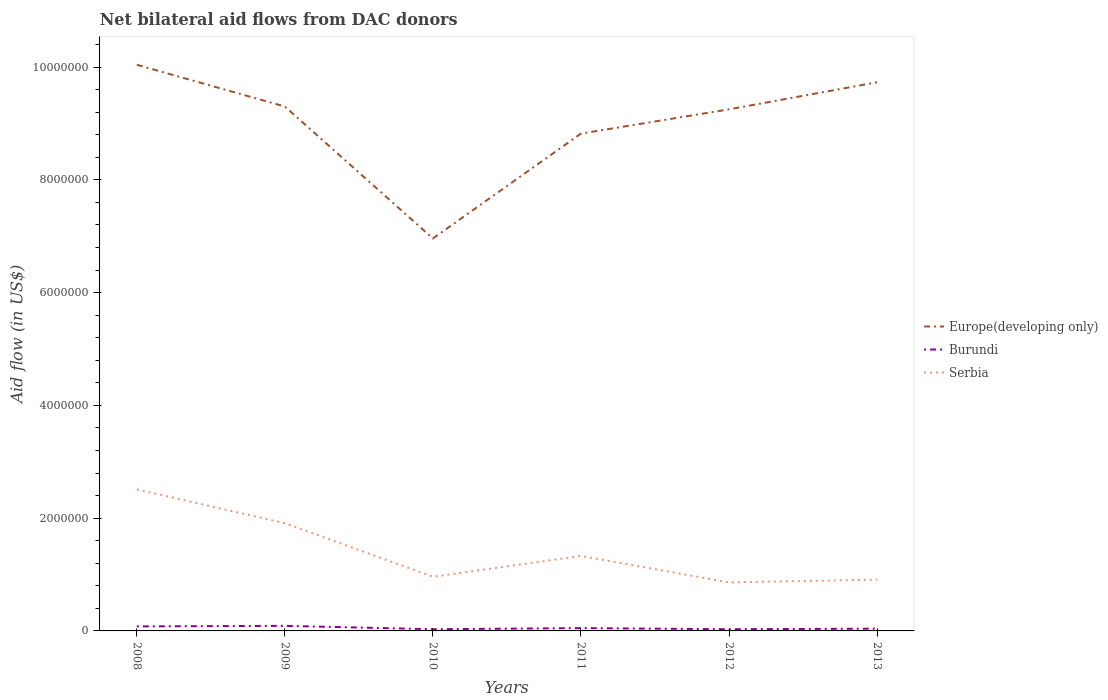Does the line corresponding to Europe(developing only) intersect with the line corresponding to Burundi?
Give a very brief answer. No. Is the number of lines equal to the number of legend labels?
Provide a succinct answer. Yes. Across all years, what is the maximum net bilateral aid flow in Serbia?
Your response must be concise. 8.60e+05. In which year was the net bilateral aid flow in Serbia maximum?
Make the answer very short. 2012. What is the total net bilateral aid flow in Serbia in the graph?
Make the answer very short. 4.70e+05. What is the difference between the highest and the second highest net bilateral aid flow in Burundi?
Your answer should be compact. 6.00e+04. What is the difference between the highest and the lowest net bilateral aid flow in Serbia?
Give a very brief answer. 2. Is the net bilateral aid flow in Serbia strictly greater than the net bilateral aid flow in Burundi over the years?
Offer a terse response. No. What is the difference between two consecutive major ticks on the Y-axis?
Provide a short and direct response. 2.00e+06. Are the values on the major ticks of Y-axis written in scientific E-notation?
Give a very brief answer. No. What is the title of the graph?
Provide a short and direct response. Net bilateral aid flows from DAC donors. What is the label or title of the X-axis?
Make the answer very short. Years. What is the label or title of the Y-axis?
Provide a succinct answer. Aid flow (in US$). What is the Aid flow (in US$) of Europe(developing only) in 2008?
Offer a very short reply. 1.00e+07. What is the Aid flow (in US$) in Serbia in 2008?
Offer a terse response. 2.51e+06. What is the Aid flow (in US$) of Europe(developing only) in 2009?
Offer a very short reply. 9.30e+06. What is the Aid flow (in US$) in Burundi in 2009?
Your answer should be very brief. 9.00e+04. What is the Aid flow (in US$) in Serbia in 2009?
Your response must be concise. 1.91e+06. What is the Aid flow (in US$) in Europe(developing only) in 2010?
Provide a short and direct response. 6.96e+06. What is the Aid flow (in US$) of Burundi in 2010?
Provide a short and direct response. 3.00e+04. What is the Aid flow (in US$) of Serbia in 2010?
Provide a short and direct response. 9.60e+05. What is the Aid flow (in US$) of Europe(developing only) in 2011?
Your answer should be compact. 8.82e+06. What is the Aid flow (in US$) of Burundi in 2011?
Provide a short and direct response. 5.00e+04. What is the Aid flow (in US$) of Serbia in 2011?
Provide a succinct answer. 1.33e+06. What is the Aid flow (in US$) of Europe(developing only) in 2012?
Keep it short and to the point. 9.25e+06. What is the Aid flow (in US$) of Serbia in 2012?
Offer a terse response. 8.60e+05. What is the Aid flow (in US$) in Europe(developing only) in 2013?
Your answer should be very brief. 9.73e+06. What is the Aid flow (in US$) of Burundi in 2013?
Offer a terse response. 4.00e+04. What is the Aid flow (in US$) of Serbia in 2013?
Offer a terse response. 9.10e+05. Across all years, what is the maximum Aid flow (in US$) in Europe(developing only)?
Provide a succinct answer. 1.00e+07. Across all years, what is the maximum Aid flow (in US$) in Burundi?
Your answer should be very brief. 9.00e+04. Across all years, what is the maximum Aid flow (in US$) of Serbia?
Your response must be concise. 2.51e+06. Across all years, what is the minimum Aid flow (in US$) of Europe(developing only)?
Your answer should be very brief. 6.96e+06. Across all years, what is the minimum Aid flow (in US$) in Burundi?
Offer a terse response. 3.00e+04. Across all years, what is the minimum Aid flow (in US$) of Serbia?
Your response must be concise. 8.60e+05. What is the total Aid flow (in US$) in Europe(developing only) in the graph?
Make the answer very short. 5.41e+07. What is the total Aid flow (in US$) of Serbia in the graph?
Your answer should be compact. 8.48e+06. What is the difference between the Aid flow (in US$) of Europe(developing only) in 2008 and that in 2009?
Give a very brief answer. 7.40e+05. What is the difference between the Aid flow (in US$) of Burundi in 2008 and that in 2009?
Your answer should be very brief. -10000. What is the difference between the Aid flow (in US$) in Europe(developing only) in 2008 and that in 2010?
Provide a short and direct response. 3.08e+06. What is the difference between the Aid flow (in US$) in Burundi in 2008 and that in 2010?
Keep it short and to the point. 5.00e+04. What is the difference between the Aid flow (in US$) in Serbia in 2008 and that in 2010?
Your answer should be compact. 1.55e+06. What is the difference between the Aid flow (in US$) in Europe(developing only) in 2008 and that in 2011?
Ensure brevity in your answer.  1.22e+06. What is the difference between the Aid flow (in US$) of Serbia in 2008 and that in 2011?
Offer a very short reply. 1.18e+06. What is the difference between the Aid flow (in US$) of Europe(developing only) in 2008 and that in 2012?
Give a very brief answer. 7.90e+05. What is the difference between the Aid flow (in US$) of Burundi in 2008 and that in 2012?
Your answer should be compact. 5.00e+04. What is the difference between the Aid flow (in US$) in Serbia in 2008 and that in 2012?
Your response must be concise. 1.65e+06. What is the difference between the Aid flow (in US$) of Europe(developing only) in 2008 and that in 2013?
Your response must be concise. 3.10e+05. What is the difference between the Aid flow (in US$) of Burundi in 2008 and that in 2013?
Make the answer very short. 4.00e+04. What is the difference between the Aid flow (in US$) of Serbia in 2008 and that in 2013?
Provide a short and direct response. 1.60e+06. What is the difference between the Aid flow (in US$) in Europe(developing only) in 2009 and that in 2010?
Provide a short and direct response. 2.34e+06. What is the difference between the Aid flow (in US$) of Serbia in 2009 and that in 2010?
Provide a succinct answer. 9.50e+05. What is the difference between the Aid flow (in US$) in Europe(developing only) in 2009 and that in 2011?
Keep it short and to the point. 4.80e+05. What is the difference between the Aid flow (in US$) in Burundi in 2009 and that in 2011?
Keep it short and to the point. 4.00e+04. What is the difference between the Aid flow (in US$) in Serbia in 2009 and that in 2011?
Keep it short and to the point. 5.80e+05. What is the difference between the Aid flow (in US$) in Europe(developing only) in 2009 and that in 2012?
Provide a succinct answer. 5.00e+04. What is the difference between the Aid flow (in US$) of Serbia in 2009 and that in 2012?
Your answer should be compact. 1.05e+06. What is the difference between the Aid flow (in US$) of Europe(developing only) in 2009 and that in 2013?
Provide a short and direct response. -4.30e+05. What is the difference between the Aid flow (in US$) in Burundi in 2009 and that in 2013?
Your answer should be compact. 5.00e+04. What is the difference between the Aid flow (in US$) of Serbia in 2009 and that in 2013?
Your response must be concise. 1.00e+06. What is the difference between the Aid flow (in US$) in Europe(developing only) in 2010 and that in 2011?
Make the answer very short. -1.86e+06. What is the difference between the Aid flow (in US$) of Burundi in 2010 and that in 2011?
Make the answer very short. -2.00e+04. What is the difference between the Aid flow (in US$) of Serbia in 2010 and that in 2011?
Your answer should be very brief. -3.70e+05. What is the difference between the Aid flow (in US$) in Europe(developing only) in 2010 and that in 2012?
Your response must be concise. -2.29e+06. What is the difference between the Aid flow (in US$) in Burundi in 2010 and that in 2012?
Make the answer very short. 0. What is the difference between the Aid flow (in US$) in Serbia in 2010 and that in 2012?
Offer a very short reply. 1.00e+05. What is the difference between the Aid flow (in US$) of Europe(developing only) in 2010 and that in 2013?
Make the answer very short. -2.77e+06. What is the difference between the Aid flow (in US$) of Burundi in 2010 and that in 2013?
Your answer should be very brief. -10000. What is the difference between the Aid flow (in US$) of Serbia in 2010 and that in 2013?
Provide a succinct answer. 5.00e+04. What is the difference between the Aid flow (in US$) in Europe(developing only) in 2011 and that in 2012?
Your response must be concise. -4.30e+05. What is the difference between the Aid flow (in US$) in Burundi in 2011 and that in 2012?
Your response must be concise. 2.00e+04. What is the difference between the Aid flow (in US$) in Serbia in 2011 and that in 2012?
Offer a very short reply. 4.70e+05. What is the difference between the Aid flow (in US$) in Europe(developing only) in 2011 and that in 2013?
Your response must be concise. -9.10e+05. What is the difference between the Aid flow (in US$) of Burundi in 2011 and that in 2013?
Your answer should be compact. 10000. What is the difference between the Aid flow (in US$) of Europe(developing only) in 2012 and that in 2013?
Keep it short and to the point. -4.80e+05. What is the difference between the Aid flow (in US$) in Burundi in 2012 and that in 2013?
Keep it short and to the point. -10000. What is the difference between the Aid flow (in US$) in Serbia in 2012 and that in 2013?
Provide a short and direct response. -5.00e+04. What is the difference between the Aid flow (in US$) in Europe(developing only) in 2008 and the Aid flow (in US$) in Burundi in 2009?
Your answer should be very brief. 9.95e+06. What is the difference between the Aid flow (in US$) in Europe(developing only) in 2008 and the Aid flow (in US$) in Serbia in 2009?
Your response must be concise. 8.13e+06. What is the difference between the Aid flow (in US$) of Burundi in 2008 and the Aid flow (in US$) of Serbia in 2009?
Provide a succinct answer. -1.83e+06. What is the difference between the Aid flow (in US$) in Europe(developing only) in 2008 and the Aid flow (in US$) in Burundi in 2010?
Your answer should be very brief. 1.00e+07. What is the difference between the Aid flow (in US$) of Europe(developing only) in 2008 and the Aid flow (in US$) of Serbia in 2010?
Provide a short and direct response. 9.08e+06. What is the difference between the Aid flow (in US$) of Burundi in 2008 and the Aid flow (in US$) of Serbia in 2010?
Offer a very short reply. -8.80e+05. What is the difference between the Aid flow (in US$) of Europe(developing only) in 2008 and the Aid flow (in US$) of Burundi in 2011?
Ensure brevity in your answer.  9.99e+06. What is the difference between the Aid flow (in US$) of Europe(developing only) in 2008 and the Aid flow (in US$) of Serbia in 2011?
Your response must be concise. 8.71e+06. What is the difference between the Aid flow (in US$) of Burundi in 2008 and the Aid flow (in US$) of Serbia in 2011?
Give a very brief answer. -1.25e+06. What is the difference between the Aid flow (in US$) of Europe(developing only) in 2008 and the Aid flow (in US$) of Burundi in 2012?
Offer a terse response. 1.00e+07. What is the difference between the Aid flow (in US$) of Europe(developing only) in 2008 and the Aid flow (in US$) of Serbia in 2012?
Ensure brevity in your answer.  9.18e+06. What is the difference between the Aid flow (in US$) of Burundi in 2008 and the Aid flow (in US$) of Serbia in 2012?
Offer a terse response. -7.80e+05. What is the difference between the Aid flow (in US$) in Europe(developing only) in 2008 and the Aid flow (in US$) in Burundi in 2013?
Your response must be concise. 1.00e+07. What is the difference between the Aid flow (in US$) in Europe(developing only) in 2008 and the Aid flow (in US$) in Serbia in 2013?
Make the answer very short. 9.13e+06. What is the difference between the Aid flow (in US$) of Burundi in 2008 and the Aid flow (in US$) of Serbia in 2013?
Your answer should be compact. -8.30e+05. What is the difference between the Aid flow (in US$) of Europe(developing only) in 2009 and the Aid flow (in US$) of Burundi in 2010?
Make the answer very short. 9.27e+06. What is the difference between the Aid flow (in US$) of Europe(developing only) in 2009 and the Aid flow (in US$) of Serbia in 2010?
Offer a very short reply. 8.34e+06. What is the difference between the Aid flow (in US$) in Burundi in 2009 and the Aid flow (in US$) in Serbia in 2010?
Provide a short and direct response. -8.70e+05. What is the difference between the Aid flow (in US$) in Europe(developing only) in 2009 and the Aid flow (in US$) in Burundi in 2011?
Offer a terse response. 9.25e+06. What is the difference between the Aid flow (in US$) in Europe(developing only) in 2009 and the Aid flow (in US$) in Serbia in 2011?
Keep it short and to the point. 7.97e+06. What is the difference between the Aid flow (in US$) in Burundi in 2009 and the Aid flow (in US$) in Serbia in 2011?
Provide a succinct answer. -1.24e+06. What is the difference between the Aid flow (in US$) of Europe(developing only) in 2009 and the Aid flow (in US$) of Burundi in 2012?
Your answer should be very brief. 9.27e+06. What is the difference between the Aid flow (in US$) of Europe(developing only) in 2009 and the Aid flow (in US$) of Serbia in 2012?
Ensure brevity in your answer.  8.44e+06. What is the difference between the Aid flow (in US$) in Burundi in 2009 and the Aid flow (in US$) in Serbia in 2012?
Offer a terse response. -7.70e+05. What is the difference between the Aid flow (in US$) of Europe(developing only) in 2009 and the Aid flow (in US$) of Burundi in 2013?
Provide a short and direct response. 9.26e+06. What is the difference between the Aid flow (in US$) in Europe(developing only) in 2009 and the Aid flow (in US$) in Serbia in 2013?
Your response must be concise. 8.39e+06. What is the difference between the Aid flow (in US$) of Burundi in 2009 and the Aid flow (in US$) of Serbia in 2013?
Offer a terse response. -8.20e+05. What is the difference between the Aid flow (in US$) of Europe(developing only) in 2010 and the Aid flow (in US$) of Burundi in 2011?
Offer a terse response. 6.91e+06. What is the difference between the Aid flow (in US$) of Europe(developing only) in 2010 and the Aid flow (in US$) of Serbia in 2011?
Ensure brevity in your answer.  5.63e+06. What is the difference between the Aid flow (in US$) in Burundi in 2010 and the Aid flow (in US$) in Serbia in 2011?
Provide a short and direct response. -1.30e+06. What is the difference between the Aid flow (in US$) of Europe(developing only) in 2010 and the Aid flow (in US$) of Burundi in 2012?
Provide a succinct answer. 6.93e+06. What is the difference between the Aid flow (in US$) in Europe(developing only) in 2010 and the Aid flow (in US$) in Serbia in 2012?
Provide a succinct answer. 6.10e+06. What is the difference between the Aid flow (in US$) in Burundi in 2010 and the Aid flow (in US$) in Serbia in 2012?
Keep it short and to the point. -8.30e+05. What is the difference between the Aid flow (in US$) of Europe(developing only) in 2010 and the Aid flow (in US$) of Burundi in 2013?
Offer a very short reply. 6.92e+06. What is the difference between the Aid flow (in US$) in Europe(developing only) in 2010 and the Aid flow (in US$) in Serbia in 2013?
Make the answer very short. 6.05e+06. What is the difference between the Aid flow (in US$) in Burundi in 2010 and the Aid flow (in US$) in Serbia in 2013?
Offer a very short reply. -8.80e+05. What is the difference between the Aid flow (in US$) of Europe(developing only) in 2011 and the Aid flow (in US$) of Burundi in 2012?
Your answer should be very brief. 8.79e+06. What is the difference between the Aid flow (in US$) of Europe(developing only) in 2011 and the Aid flow (in US$) of Serbia in 2012?
Provide a succinct answer. 7.96e+06. What is the difference between the Aid flow (in US$) of Burundi in 2011 and the Aid flow (in US$) of Serbia in 2012?
Keep it short and to the point. -8.10e+05. What is the difference between the Aid flow (in US$) in Europe(developing only) in 2011 and the Aid flow (in US$) in Burundi in 2013?
Give a very brief answer. 8.78e+06. What is the difference between the Aid flow (in US$) of Europe(developing only) in 2011 and the Aid flow (in US$) of Serbia in 2013?
Your answer should be very brief. 7.91e+06. What is the difference between the Aid flow (in US$) of Burundi in 2011 and the Aid flow (in US$) of Serbia in 2013?
Keep it short and to the point. -8.60e+05. What is the difference between the Aid flow (in US$) in Europe(developing only) in 2012 and the Aid flow (in US$) in Burundi in 2013?
Your answer should be compact. 9.21e+06. What is the difference between the Aid flow (in US$) in Europe(developing only) in 2012 and the Aid flow (in US$) in Serbia in 2013?
Give a very brief answer. 8.34e+06. What is the difference between the Aid flow (in US$) of Burundi in 2012 and the Aid flow (in US$) of Serbia in 2013?
Make the answer very short. -8.80e+05. What is the average Aid flow (in US$) in Europe(developing only) per year?
Offer a terse response. 9.02e+06. What is the average Aid flow (in US$) in Burundi per year?
Your answer should be compact. 5.33e+04. What is the average Aid flow (in US$) of Serbia per year?
Provide a succinct answer. 1.41e+06. In the year 2008, what is the difference between the Aid flow (in US$) of Europe(developing only) and Aid flow (in US$) of Burundi?
Keep it short and to the point. 9.96e+06. In the year 2008, what is the difference between the Aid flow (in US$) in Europe(developing only) and Aid flow (in US$) in Serbia?
Offer a terse response. 7.53e+06. In the year 2008, what is the difference between the Aid flow (in US$) in Burundi and Aid flow (in US$) in Serbia?
Give a very brief answer. -2.43e+06. In the year 2009, what is the difference between the Aid flow (in US$) in Europe(developing only) and Aid flow (in US$) in Burundi?
Keep it short and to the point. 9.21e+06. In the year 2009, what is the difference between the Aid flow (in US$) in Europe(developing only) and Aid flow (in US$) in Serbia?
Your response must be concise. 7.39e+06. In the year 2009, what is the difference between the Aid flow (in US$) of Burundi and Aid flow (in US$) of Serbia?
Provide a short and direct response. -1.82e+06. In the year 2010, what is the difference between the Aid flow (in US$) in Europe(developing only) and Aid flow (in US$) in Burundi?
Make the answer very short. 6.93e+06. In the year 2010, what is the difference between the Aid flow (in US$) of Europe(developing only) and Aid flow (in US$) of Serbia?
Provide a succinct answer. 6.00e+06. In the year 2010, what is the difference between the Aid flow (in US$) of Burundi and Aid flow (in US$) of Serbia?
Your response must be concise. -9.30e+05. In the year 2011, what is the difference between the Aid flow (in US$) of Europe(developing only) and Aid flow (in US$) of Burundi?
Give a very brief answer. 8.77e+06. In the year 2011, what is the difference between the Aid flow (in US$) of Europe(developing only) and Aid flow (in US$) of Serbia?
Provide a short and direct response. 7.49e+06. In the year 2011, what is the difference between the Aid flow (in US$) in Burundi and Aid flow (in US$) in Serbia?
Offer a very short reply. -1.28e+06. In the year 2012, what is the difference between the Aid flow (in US$) of Europe(developing only) and Aid flow (in US$) of Burundi?
Your answer should be compact. 9.22e+06. In the year 2012, what is the difference between the Aid flow (in US$) in Europe(developing only) and Aid flow (in US$) in Serbia?
Your response must be concise. 8.39e+06. In the year 2012, what is the difference between the Aid flow (in US$) of Burundi and Aid flow (in US$) of Serbia?
Ensure brevity in your answer.  -8.30e+05. In the year 2013, what is the difference between the Aid flow (in US$) of Europe(developing only) and Aid flow (in US$) of Burundi?
Offer a very short reply. 9.69e+06. In the year 2013, what is the difference between the Aid flow (in US$) of Europe(developing only) and Aid flow (in US$) of Serbia?
Provide a succinct answer. 8.82e+06. In the year 2013, what is the difference between the Aid flow (in US$) of Burundi and Aid flow (in US$) of Serbia?
Your answer should be very brief. -8.70e+05. What is the ratio of the Aid flow (in US$) of Europe(developing only) in 2008 to that in 2009?
Your response must be concise. 1.08. What is the ratio of the Aid flow (in US$) in Burundi in 2008 to that in 2009?
Ensure brevity in your answer.  0.89. What is the ratio of the Aid flow (in US$) in Serbia in 2008 to that in 2009?
Provide a short and direct response. 1.31. What is the ratio of the Aid flow (in US$) of Europe(developing only) in 2008 to that in 2010?
Provide a short and direct response. 1.44. What is the ratio of the Aid flow (in US$) in Burundi in 2008 to that in 2010?
Offer a terse response. 2.67. What is the ratio of the Aid flow (in US$) in Serbia in 2008 to that in 2010?
Your answer should be very brief. 2.61. What is the ratio of the Aid flow (in US$) of Europe(developing only) in 2008 to that in 2011?
Keep it short and to the point. 1.14. What is the ratio of the Aid flow (in US$) in Serbia in 2008 to that in 2011?
Give a very brief answer. 1.89. What is the ratio of the Aid flow (in US$) of Europe(developing only) in 2008 to that in 2012?
Ensure brevity in your answer.  1.09. What is the ratio of the Aid flow (in US$) in Burundi in 2008 to that in 2012?
Provide a succinct answer. 2.67. What is the ratio of the Aid flow (in US$) in Serbia in 2008 to that in 2012?
Provide a short and direct response. 2.92. What is the ratio of the Aid flow (in US$) of Europe(developing only) in 2008 to that in 2013?
Give a very brief answer. 1.03. What is the ratio of the Aid flow (in US$) of Serbia in 2008 to that in 2013?
Keep it short and to the point. 2.76. What is the ratio of the Aid flow (in US$) of Europe(developing only) in 2009 to that in 2010?
Keep it short and to the point. 1.34. What is the ratio of the Aid flow (in US$) of Burundi in 2009 to that in 2010?
Make the answer very short. 3. What is the ratio of the Aid flow (in US$) in Serbia in 2009 to that in 2010?
Offer a very short reply. 1.99. What is the ratio of the Aid flow (in US$) of Europe(developing only) in 2009 to that in 2011?
Give a very brief answer. 1.05. What is the ratio of the Aid flow (in US$) in Serbia in 2009 to that in 2011?
Your answer should be very brief. 1.44. What is the ratio of the Aid flow (in US$) in Europe(developing only) in 2009 to that in 2012?
Give a very brief answer. 1.01. What is the ratio of the Aid flow (in US$) of Burundi in 2009 to that in 2012?
Your answer should be compact. 3. What is the ratio of the Aid flow (in US$) in Serbia in 2009 to that in 2012?
Make the answer very short. 2.22. What is the ratio of the Aid flow (in US$) in Europe(developing only) in 2009 to that in 2013?
Ensure brevity in your answer.  0.96. What is the ratio of the Aid flow (in US$) of Burundi in 2009 to that in 2013?
Ensure brevity in your answer.  2.25. What is the ratio of the Aid flow (in US$) in Serbia in 2009 to that in 2013?
Keep it short and to the point. 2.1. What is the ratio of the Aid flow (in US$) in Europe(developing only) in 2010 to that in 2011?
Make the answer very short. 0.79. What is the ratio of the Aid flow (in US$) in Serbia in 2010 to that in 2011?
Make the answer very short. 0.72. What is the ratio of the Aid flow (in US$) of Europe(developing only) in 2010 to that in 2012?
Provide a succinct answer. 0.75. What is the ratio of the Aid flow (in US$) in Burundi in 2010 to that in 2012?
Your answer should be very brief. 1. What is the ratio of the Aid flow (in US$) of Serbia in 2010 to that in 2012?
Your response must be concise. 1.12. What is the ratio of the Aid flow (in US$) of Europe(developing only) in 2010 to that in 2013?
Offer a terse response. 0.72. What is the ratio of the Aid flow (in US$) in Burundi in 2010 to that in 2013?
Your answer should be compact. 0.75. What is the ratio of the Aid flow (in US$) in Serbia in 2010 to that in 2013?
Give a very brief answer. 1.05. What is the ratio of the Aid flow (in US$) of Europe(developing only) in 2011 to that in 2012?
Your answer should be very brief. 0.95. What is the ratio of the Aid flow (in US$) in Burundi in 2011 to that in 2012?
Offer a terse response. 1.67. What is the ratio of the Aid flow (in US$) in Serbia in 2011 to that in 2012?
Make the answer very short. 1.55. What is the ratio of the Aid flow (in US$) of Europe(developing only) in 2011 to that in 2013?
Provide a succinct answer. 0.91. What is the ratio of the Aid flow (in US$) of Burundi in 2011 to that in 2013?
Make the answer very short. 1.25. What is the ratio of the Aid flow (in US$) in Serbia in 2011 to that in 2013?
Your answer should be very brief. 1.46. What is the ratio of the Aid flow (in US$) of Europe(developing only) in 2012 to that in 2013?
Make the answer very short. 0.95. What is the ratio of the Aid flow (in US$) in Serbia in 2012 to that in 2013?
Your answer should be very brief. 0.95. What is the difference between the highest and the second highest Aid flow (in US$) of Burundi?
Ensure brevity in your answer.  10000. What is the difference between the highest and the second highest Aid flow (in US$) in Serbia?
Provide a succinct answer. 6.00e+05. What is the difference between the highest and the lowest Aid flow (in US$) of Europe(developing only)?
Provide a short and direct response. 3.08e+06. What is the difference between the highest and the lowest Aid flow (in US$) of Serbia?
Give a very brief answer. 1.65e+06. 